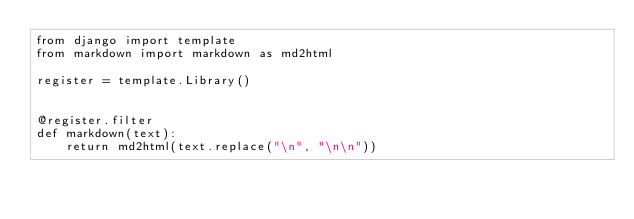<code> <loc_0><loc_0><loc_500><loc_500><_Python_>from django import template
from markdown import markdown as md2html

register = template.Library()


@register.filter
def markdown(text):
    return md2html(text.replace("\n", "\n\n"))
</code> 